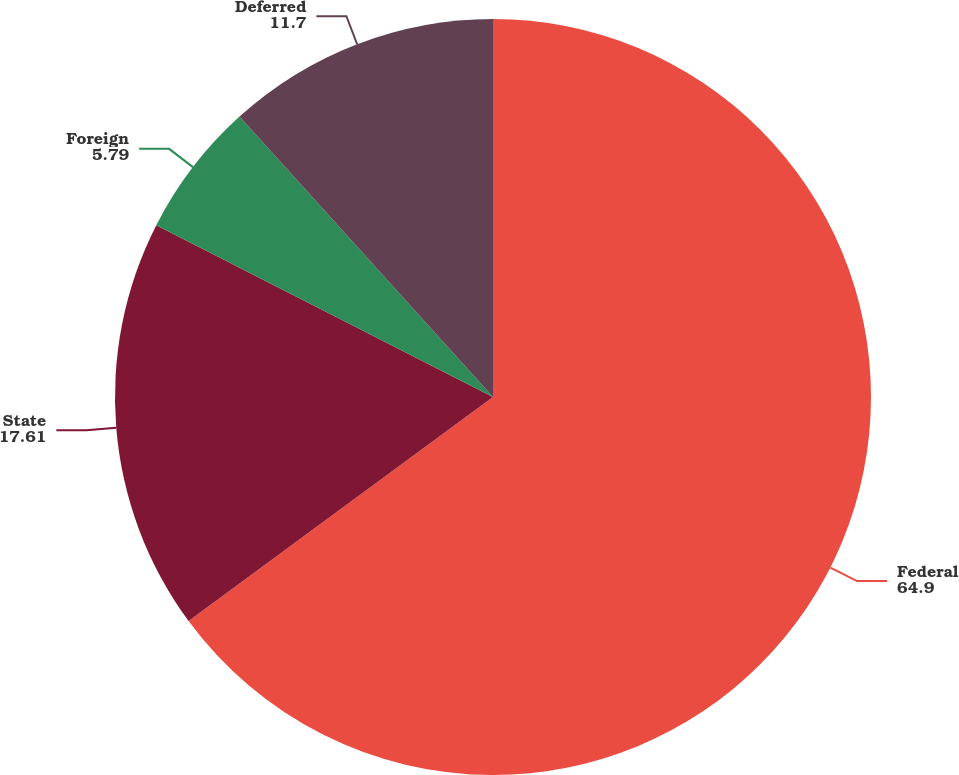<chart> <loc_0><loc_0><loc_500><loc_500><pie_chart><fcel>Federal<fcel>State<fcel>Foreign<fcel>Deferred<nl><fcel>64.9%<fcel>17.61%<fcel>5.79%<fcel>11.7%<nl></chart> 